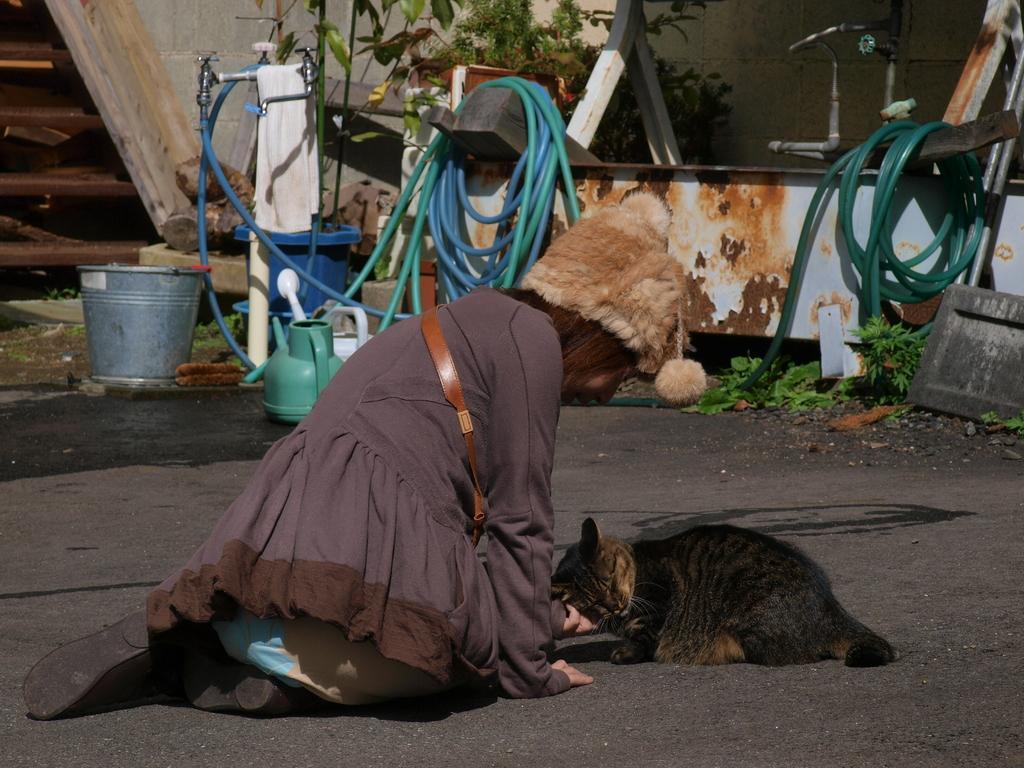How would you summarize this image in a sentence or two? In the foreground of this picture, there is a woman sitting on the ground in front of a cat. In the background, we can see pipes, tubs, tap, tree, plant and the wall. 